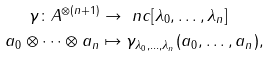<formula> <loc_0><loc_0><loc_500><loc_500>\gamma \colon A ^ { \otimes ( n + 1 ) } & \to \ n c [ \lambda _ { 0 } , \dots , \lambda _ { n } ] \\ a _ { 0 } \otimes \dots \otimes a _ { n } & \mapsto \gamma _ { \lambda _ { 0 } , \dots , \lambda _ { n } } ( a _ { 0 } , \dots , a _ { n } ) ,</formula> 